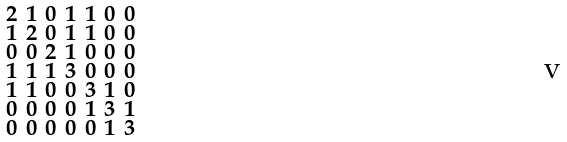Convert formula to latex. <formula><loc_0><loc_0><loc_500><loc_500>\begin{smallmatrix} 2 & 1 & 0 & 1 & 1 & 0 & 0 \\ 1 & 2 & 0 & 1 & 1 & 0 & 0 \\ 0 & 0 & 2 & 1 & 0 & 0 & 0 \\ 1 & 1 & 1 & 3 & 0 & 0 & 0 \\ 1 & 1 & 0 & 0 & 3 & 1 & 0 \\ 0 & 0 & 0 & 0 & 1 & 3 & 1 \\ 0 & 0 & 0 & 0 & 0 & 1 & 3 \end{smallmatrix}</formula> 